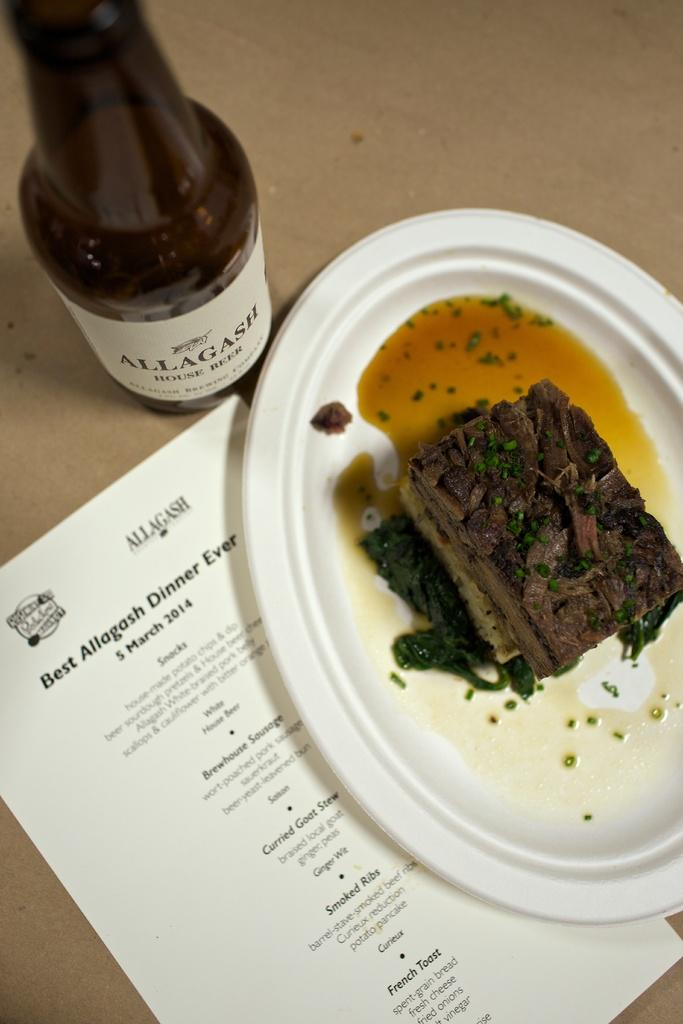What is on the plate that is visible in the image? There is a plate with food in the image. What else can be seen beside the plate? There is a paper with information beside the plate. What type of container is present in the image? There is a bottle in the image. How many tomatoes are on the plate in the image? There is no information about tomatoes on the plate in the image. What is the source of fear in the image? There is no indication of fear or any fear-inducing elements in the image. 